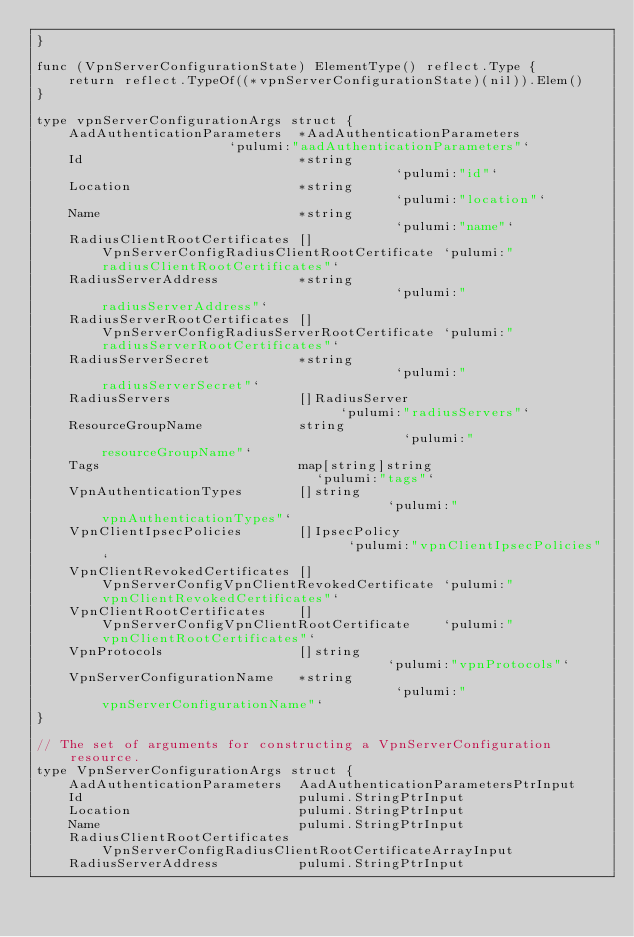<code> <loc_0><loc_0><loc_500><loc_500><_Go_>}

func (VpnServerConfigurationState) ElementType() reflect.Type {
	return reflect.TypeOf((*vpnServerConfigurationState)(nil)).Elem()
}

type vpnServerConfigurationArgs struct {
	AadAuthenticationParameters  *AadAuthenticationParameters                 `pulumi:"aadAuthenticationParameters"`
	Id                           *string                                      `pulumi:"id"`
	Location                     *string                                      `pulumi:"location"`
	Name                         *string                                      `pulumi:"name"`
	RadiusClientRootCertificates []VpnServerConfigRadiusClientRootCertificate `pulumi:"radiusClientRootCertificates"`
	RadiusServerAddress          *string                                      `pulumi:"radiusServerAddress"`
	RadiusServerRootCertificates []VpnServerConfigRadiusServerRootCertificate `pulumi:"radiusServerRootCertificates"`
	RadiusServerSecret           *string                                      `pulumi:"radiusServerSecret"`
	RadiusServers                []RadiusServer                               `pulumi:"radiusServers"`
	ResourceGroupName            string                                       `pulumi:"resourceGroupName"`
	Tags                         map[string]string                            `pulumi:"tags"`
	VpnAuthenticationTypes       []string                                     `pulumi:"vpnAuthenticationTypes"`
	VpnClientIpsecPolicies       []IpsecPolicy                                `pulumi:"vpnClientIpsecPolicies"`
	VpnClientRevokedCertificates []VpnServerConfigVpnClientRevokedCertificate `pulumi:"vpnClientRevokedCertificates"`
	VpnClientRootCertificates    []VpnServerConfigVpnClientRootCertificate    `pulumi:"vpnClientRootCertificates"`
	VpnProtocols                 []string                                     `pulumi:"vpnProtocols"`
	VpnServerConfigurationName   *string                                      `pulumi:"vpnServerConfigurationName"`
}

// The set of arguments for constructing a VpnServerConfiguration resource.
type VpnServerConfigurationArgs struct {
	AadAuthenticationParameters  AadAuthenticationParametersPtrInput
	Id                           pulumi.StringPtrInput
	Location                     pulumi.StringPtrInput
	Name                         pulumi.StringPtrInput
	RadiusClientRootCertificates VpnServerConfigRadiusClientRootCertificateArrayInput
	RadiusServerAddress          pulumi.StringPtrInput</code> 